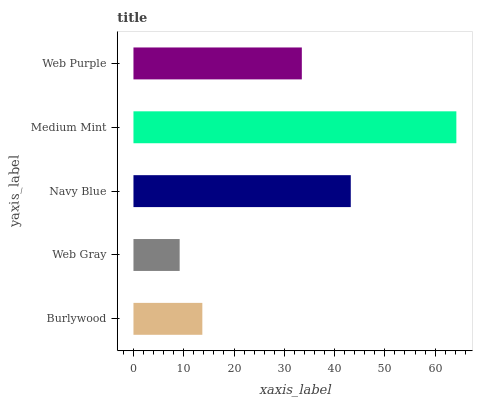Is Web Gray the minimum?
Answer yes or no. Yes. Is Medium Mint the maximum?
Answer yes or no. Yes. Is Navy Blue the minimum?
Answer yes or no. No. Is Navy Blue the maximum?
Answer yes or no. No. Is Navy Blue greater than Web Gray?
Answer yes or no. Yes. Is Web Gray less than Navy Blue?
Answer yes or no. Yes. Is Web Gray greater than Navy Blue?
Answer yes or no. No. Is Navy Blue less than Web Gray?
Answer yes or no. No. Is Web Purple the high median?
Answer yes or no. Yes. Is Web Purple the low median?
Answer yes or no. Yes. Is Medium Mint the high median?
Answer yes or no. No. Is Medium Mint the low median?
Answer yes or no. No. 